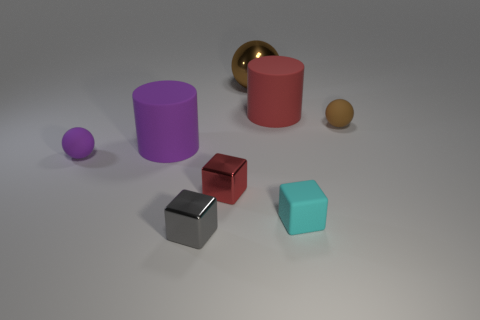What is the shape of the large rubber thing behind the big rubber thing to the left of the big brown metal ball? The large rubber object behind the big rubber thing to the left of the large brown metallic sphere is a cylinder. Its smooth, curved surface and circular base distinguish it as such, and its purple color gives it a distinct appearance among the other objects. 